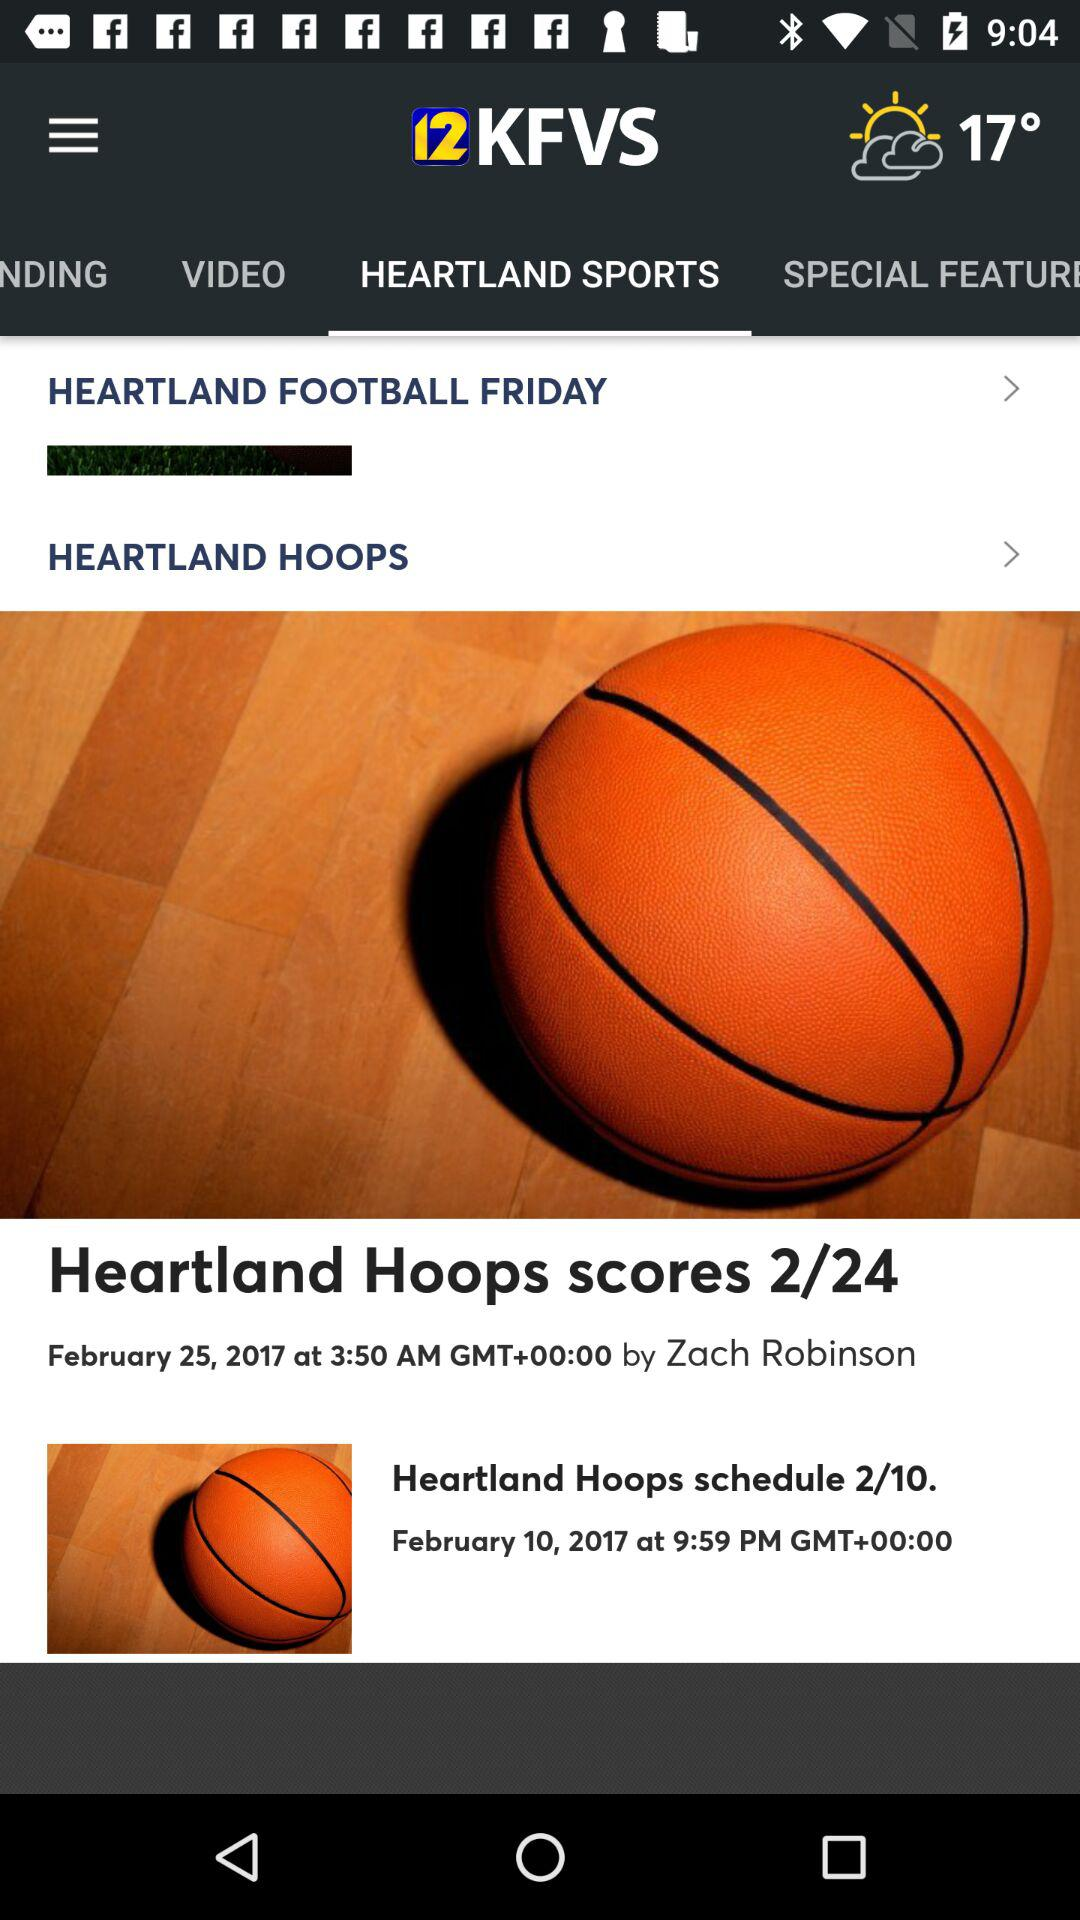What is the temperature? The temperature is 17°. 